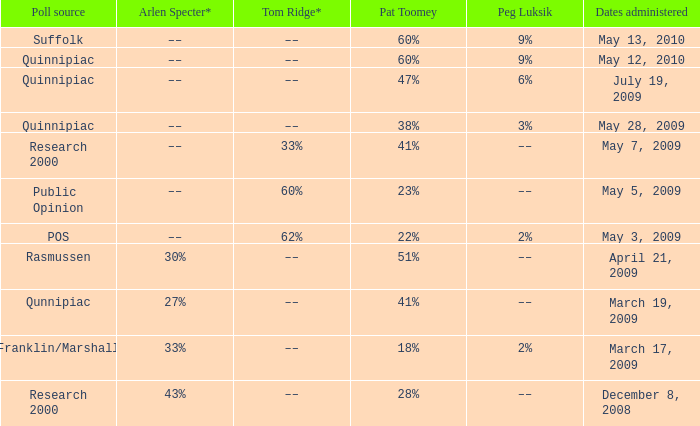Which Poll source has Pat Toomey of 23%? Public Opinion. 